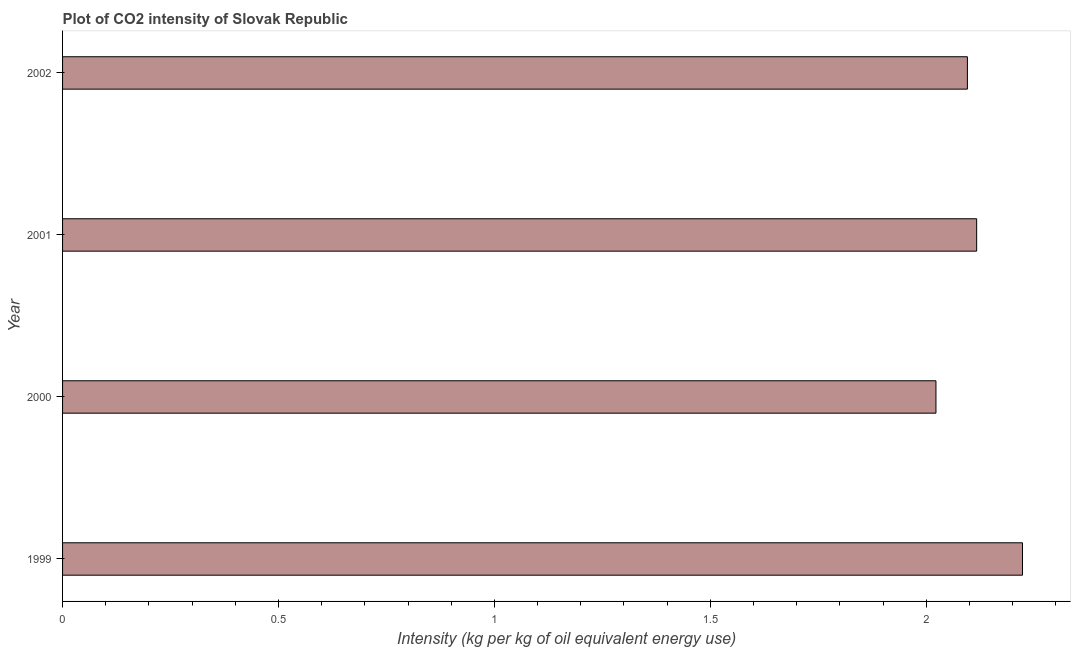Does the graph contain any zero values?
Offer a very short reply. No. What is the title of the graph?
Keep it short and to the point. Plot of CO2 intensity of Slovak Republic. What is the label or title of the X-axis?
Your response must be concise. Intensity (kg per kg of oil equivalent energy use). What is the co2 intensity in 2002?
Provide a succinct answer. 2.1. Across all years, what is the maximum co2 intensity?
Give a very brief answer. 2.22. Across all years, what is the minimum co2 intensity?
Provide a short and direct response. 2.02. In which year was the co2 intensity maximum?
Give a very brief answer. 1999. What is the sum of the co2 intensity?
Make the answer very short. 8.46. What is the difference between the co2 intensity in 1999 and 2001?
Offer a terse response. 0.11. What is the average co2 intensity per year?
Give a very brief answer. 2.11. What is the median co2 intensity?
Offer a very short reply. 2.11. Do a majority of the years between 2002 and 2001 (inclusive) have co2 intensity greater than 0.2 kg?
Provide a short and direct response. No. What is the difference between the highest and the second highest co2 intensity?
Your response must be concise. 0.11. Is the sum of the co2 intensity in 1999 and 2001 greater than the maximum co2 intensity across all years?
Make the answer very short. Yes. In how many years, is the co2 intensity greater than the average co2 intensity taken over all years?
Your response must be concise. 2. How many bars are there?
Your answer should be compact. 4. What is the Intensity (kg per kg of oil equivalent energy use) of 1999?
Provide a succinct answer. 2.22. What is the Intensity (kg per kg of oil equivalent energy use) in 2000?
Your answer should be compact. 2.02. What is the Intensity (kg per kg of oil equivalent energy use) of 2001?
Keep it short and to the point. 2.12. What is the Intensity (kg per kg of oil equivalent energy use) in 2002?
Your answer should be very brief. 2.1. What is the difference between the Intensity (kg per kg of oil equivalent energy use) in 1999 and 2000?
Your answer should be very brief. 0.2. What is the difference between the Intensity (kg per kg of oil equivalent energy use) in 1999 and 2001?
Keep it short and to the point. 0.11. What is the difference between the Intensity (kg per kg of oil equivalent energy use) in 1999 and 2002?
Your answer should be compact. 0.13. What is the difference between the Intensity (kg per kg of oil equivalent energy use) in 2000 and 2001?
Offer a terse response. -0.09. What is the difference between the Intensity (kg per kg of oil equivalent energy use) in 2000 and 2002?
Offer a very short reply. -0.07. What is the difference between the Intensity (kg per kg of oil equivalent energy use) in 2001 and 2002?
Make the answer very short. 0.02. What is the ratio of the Intensity (kg per kg of oil equivalent energy use) in 1999 to that in 2000?
Make the answer very short. 1.1. What is the ratio of the Intensity (kg per kg of oil equivalent energy use) in 1999 to that in 2001?
Offer a terse response. 1.05. What is the ratio of the Intensity (kg per kg of oil equivalent energy use) in 1999 to that in 2002?
Your answer should be compact. 1.06. What is the ratio of the Intensity (kg per kg of oil equivalent energy use) in 2000 to that in 2001?
Offer a very short reply. 0.95. What is the ratio of the Intensity (kg per kg of oil equivalent energy use) in 2001 to that in 2002?
Your answer should be compact. 1.01. 